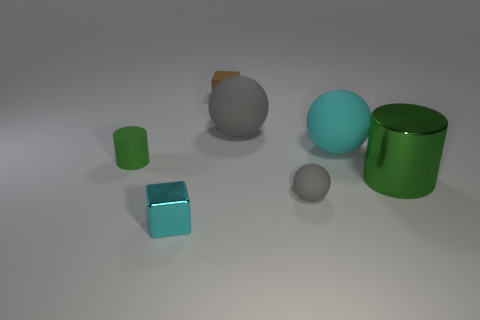Add 1 gray cylinders. How many objects exist? 8 Subtract all cubes. How many objects are left? 5 Subtract all gray matte balls. Subtract all big gray objects. How many objects are left? 4 Add 4 small gray things. How many small gray things are left? 5 Add 7 red spheres. How many red spheres exist? 7 Subtract 0 red balls. How many objects are left? 7 